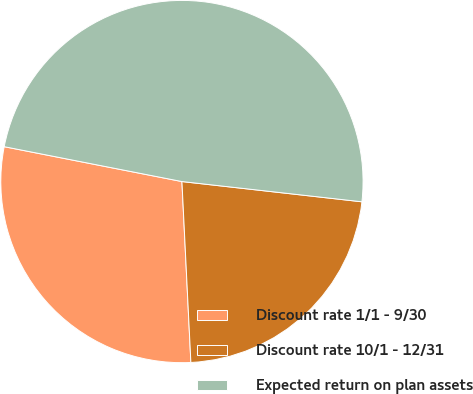<chart> <loc_0><loc_0><loc_500><loc_500><pie_chart><fcel>Discount rate 1/1 - 9/30<fcel>Discount rate 10/1 - 12/31<fcel>Expected return on plan assets<nl><fcel>28.87%<fcel>22.43%<fcel>48.7%<nl></chart> 